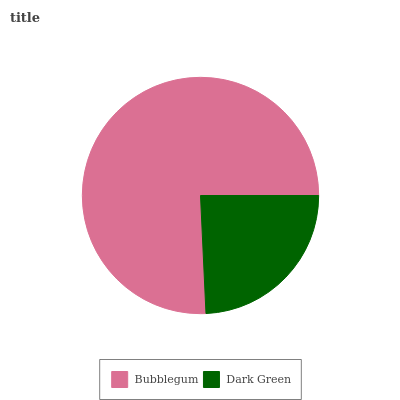Is Dark Green the minimum?
Answer yes or no. Yes. Is Bubblegum the maximum?
Answer yes or no. Yes. Is Dark Green the maximum?
Answer yes or no. No. Is Bubblegum greater than Dark Green?
Answer yes or no. Yes. Is Dark Green less than Bubblegum?
Answer yes or no. Yes. Is Dark Green greater than Bubblegum?
Answer yes or no. No. Is Bubblegum less than Dark Green?
Answer yes or no. No. Is Bubblegum the high median?
Answer yes or no. Yes. Is Dark Green the low median?
Answer yes or no. Yes. Is Dark Green the high median?
Answer yes or no. No. Is Bubblegum the low median?
Answer yes or no. No. 